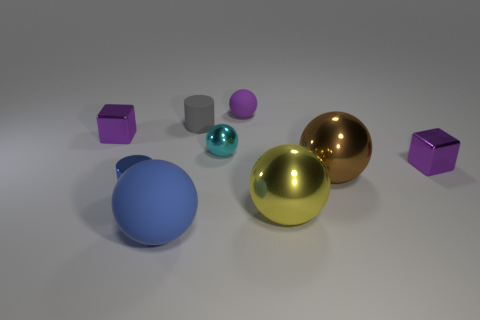What is the shape of the tiny purple shiny object that is right of the large matte thing in front of the large brown metal sphere?
Make the answer very short. Cube. How many tiny spheres are in front of the tiny purple thing that is left of the small blue shiny thing?
Offer a terse response. 1. What is the material of the sphere that is in front of the gray rubber cylinder and behind the brown object?
Provide a short and direct response. Metal. What is the shape of the blue thing that is the same size as the brown ball?
Provide a short and direct response. Sphere. The rubber ball that is behind the purple cube that is on the left side of the small purple cube that is on the right side of the small purple matte thing is what color?
Your answer should be very brief. Purple. How many things are tiny purple shiny things left of the big blue matte object or cylinders?
Provide a succinct answer. 3. What is the material of the brown sphere that is the same size as the yellow metallic thing?
Make the answer very short. Metal. There is a small cube on the left side of the matte ball in front of the cylinder to the right of the blue sphere; what is it made of?
Ensure brevity in your answer.  Metal. The small rubber cylinder has what color?
Offer a terse response. Gray. How many tiny objects are blue things or purple rubber balls?
Your answer should be compact. 2. 